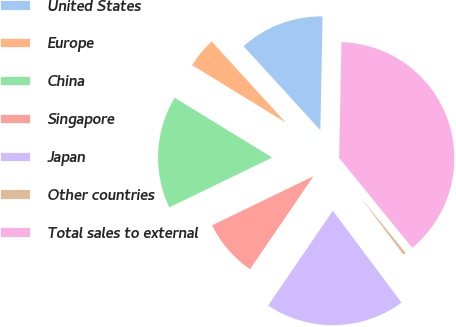Convert chart. <chart><loc_0><loc_0><loc_500><loc_500><pie_chart><fcel>United States<fcel>Europe<fcel>China<fcel>Singapore<fcel>Japan<fcel>Other countries<fcel>Total sales to external<nl><fcel>12.1%<fcel>4.47%<fcel>15.92%<fcel>8.29%<fcel>19.74%<fcel>0.65%<fcel>38.82%<nl></chart> 